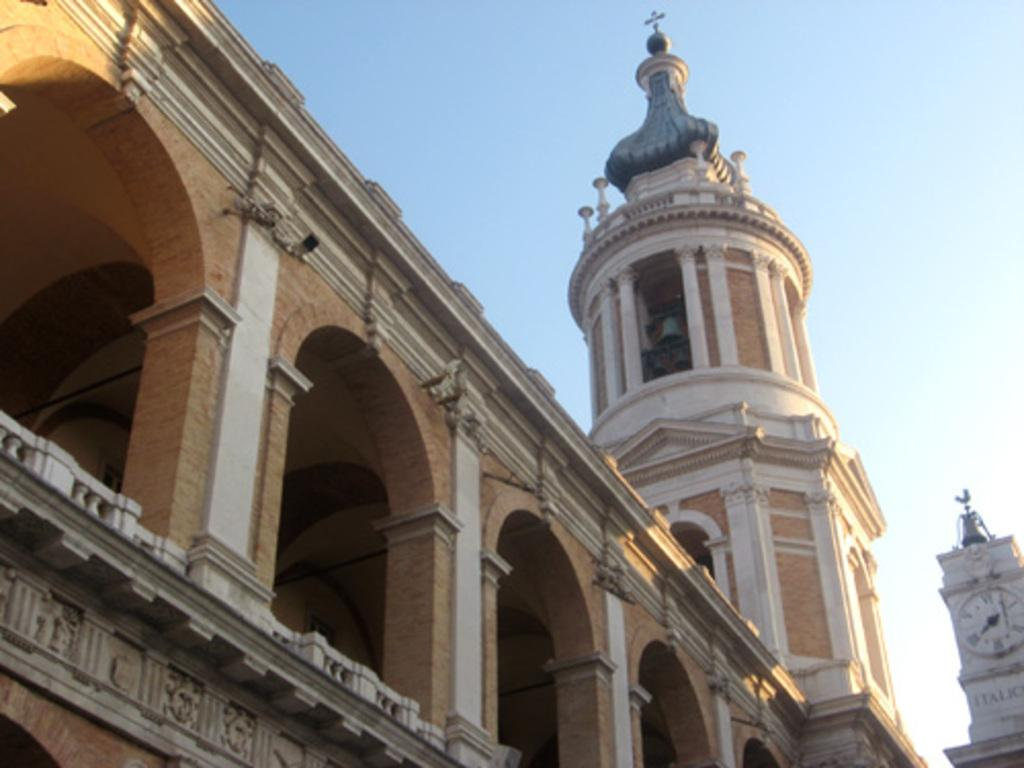What type of structure is present in the image? There is a building in the image. What part of the natural environment is visible in the image? The sky is visible in the image. Where is the throne located in the image? There is no throne present in the image. How many men can be seen sleeping in the image? There are no men or sleeping figures present in the image. 